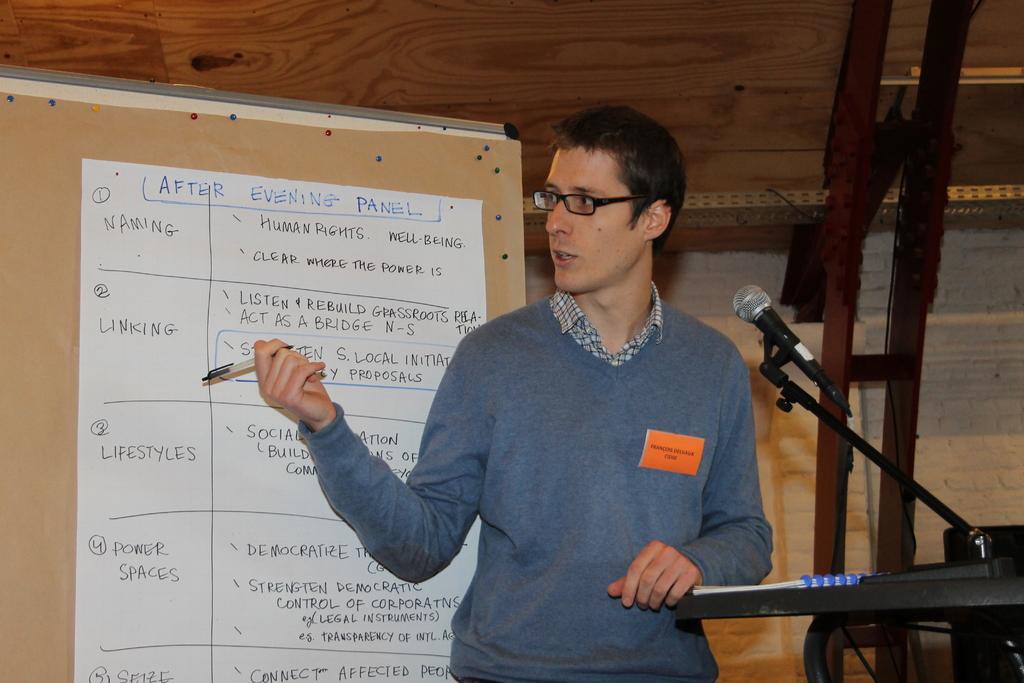How would you summarize this image in a sentence or two? In this image in the center there is a person standing and speaking. On the right side there is a podium and on the top of the podium there is a mic and there is a book and the person is holding a pen in his hand. In the background there is a board with some text written on it and there is wall behind the board and there is a stand. 